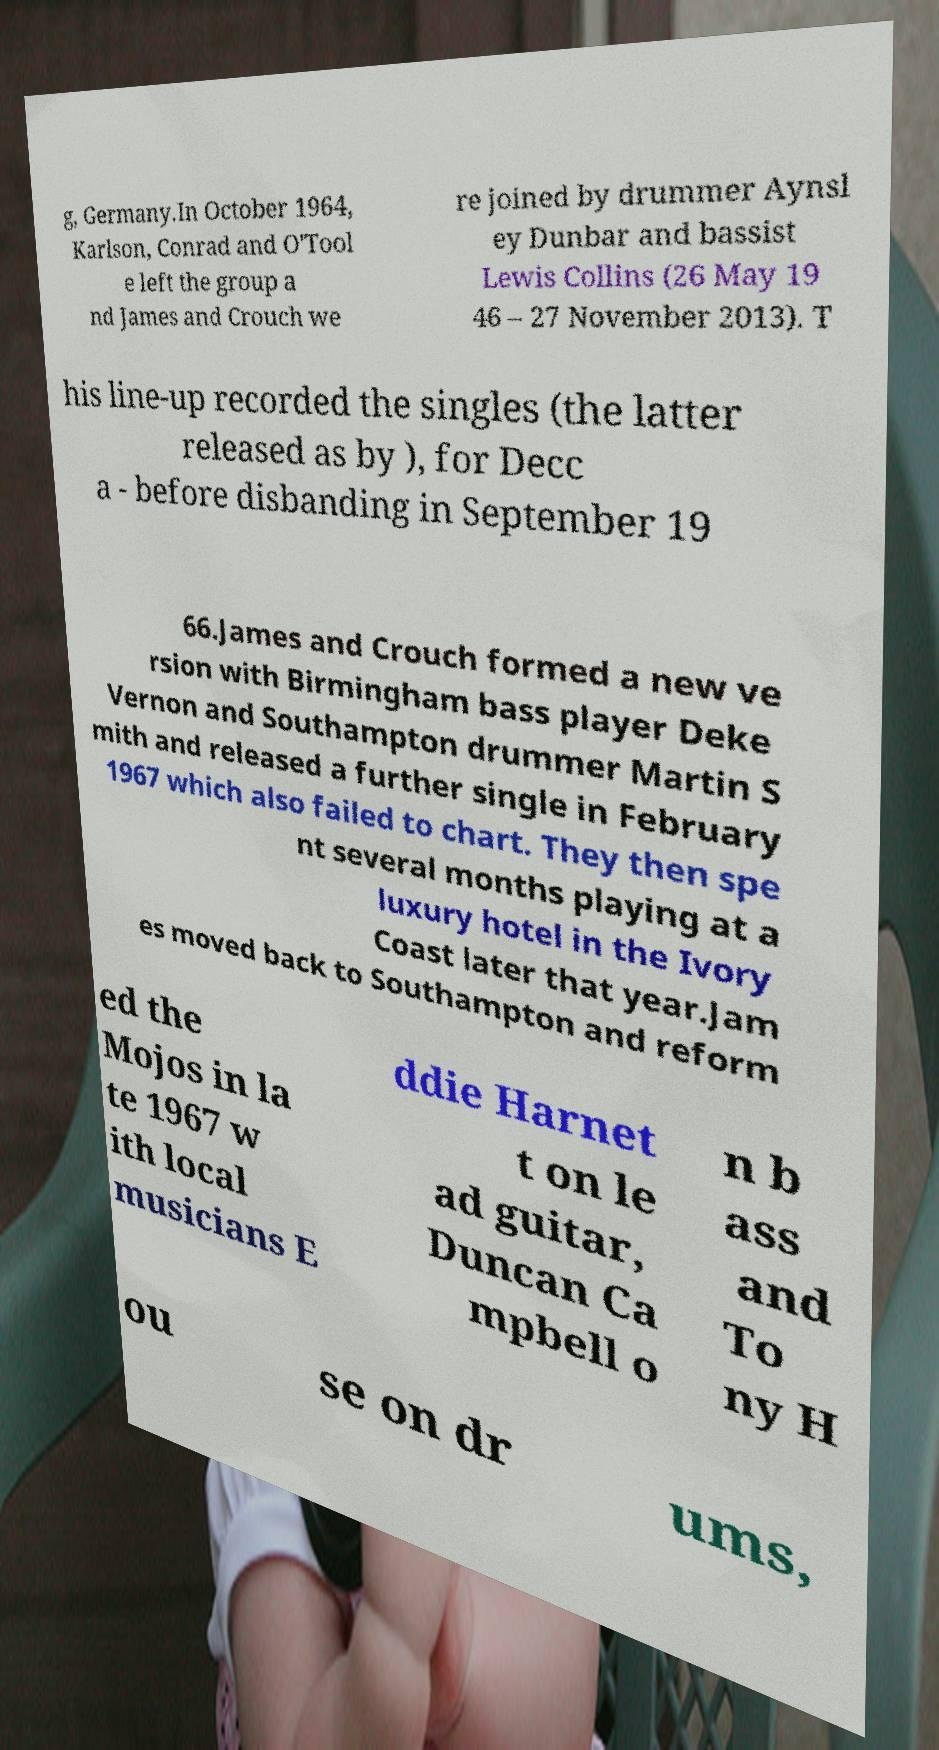Please read and relay the text visible in this image. What does it say? g, Germany.In October 1964, Karlson, Conrad and O'Tool e left the group a nd James and Crouch we re joined by drummer Aynsl ey Dunbar and bassist Lewis Collins (26 May 19 46 – 27 November 2013). T his line-up recorded the singles (the latter released as by ), for Decc a - before disbanding in September 19 66.James and Crouch formed a new ve rsion with Birmingham bass player Deke Vernon and Southampton drummer Martin S mith and released a further single in February 1967 which also failed to chart. They then spe nt several months playing at a luxury hotel in the Ivory Coast later that year.Jam es moved back to Southampton and reform ed the Mojos in la te 1967 w ith local musicians E ddie Harnet t on le ad guitar, Duncan Ca mpbell o n b ass and To ny H ou se on dr ums, 